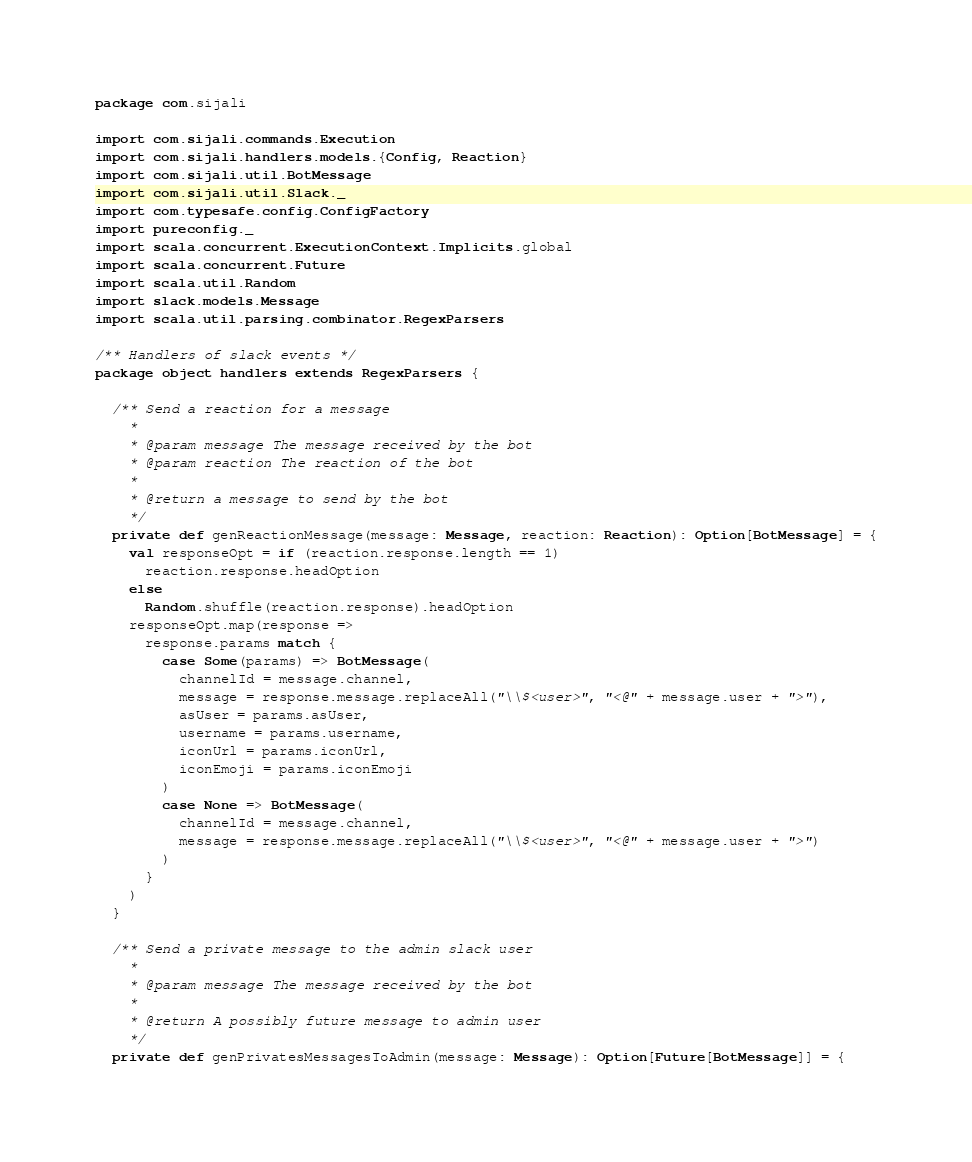<code> <loc_0><loc_0><loc_500><loc_500><_Scala_>package com.sijali

import com.sijali.commands.Execution
import com.sijali.handlers.models.{Config, Reaction}
import com.sijali.util.BotMessage
import com.sijali.util.Slack._
import com.typesafe.config.ConfigFactory
import pureconfig._
import scala.concurrent.ExecutionContext.Implicits.global
import scala.concurrent.Future
import scala.util.Random
import slack.models.Message
import scala.util.parsing.combinator.RegexParsers

/** Handlers of slack events */
package object handlers extends RegexParsers {

  /** Send a reaction for a message
    *
    * @param message The message received by the bot
    * @param reaction The reaction of the bot
    *
    * @return a message to send by the bot
    */
  private def genReactionMessage(message: Message, reaction: Reaction): Option[BotMessage] = {
    val responseOpt = if (reaction.response.length == 1)
      reaction.response.headOption
    else
      Random.shuffle(reaction.response).headOption
    responseOpt.map(response =>
      response.params match {
        case Some(params) => BotMessage(
          channelId = message.channel,
          message = response.message.replaceAll("\\$<user>", "<@" + message.user + ">"),
          asUser = params.asUser,
          username = params.username,
          iconUrl = params.iconUrl,
          iconEmoji = params.iconEmoji
        )
        case None => BotMessage(
          channelId = message.channel,
          message = response.message.replaceAll("\\$<user>", "<@" + message.user + ">")
        )
      }
    )
  }

  /** Send a private message to the admin slack user
    *
    * @param message The message received by the bot
    *
    * @return A possibly future message to admin user
    */
  private def genPrivatesMessagesToAdmin(message: Message): Option[Future[BotMessage]] = {</code> 